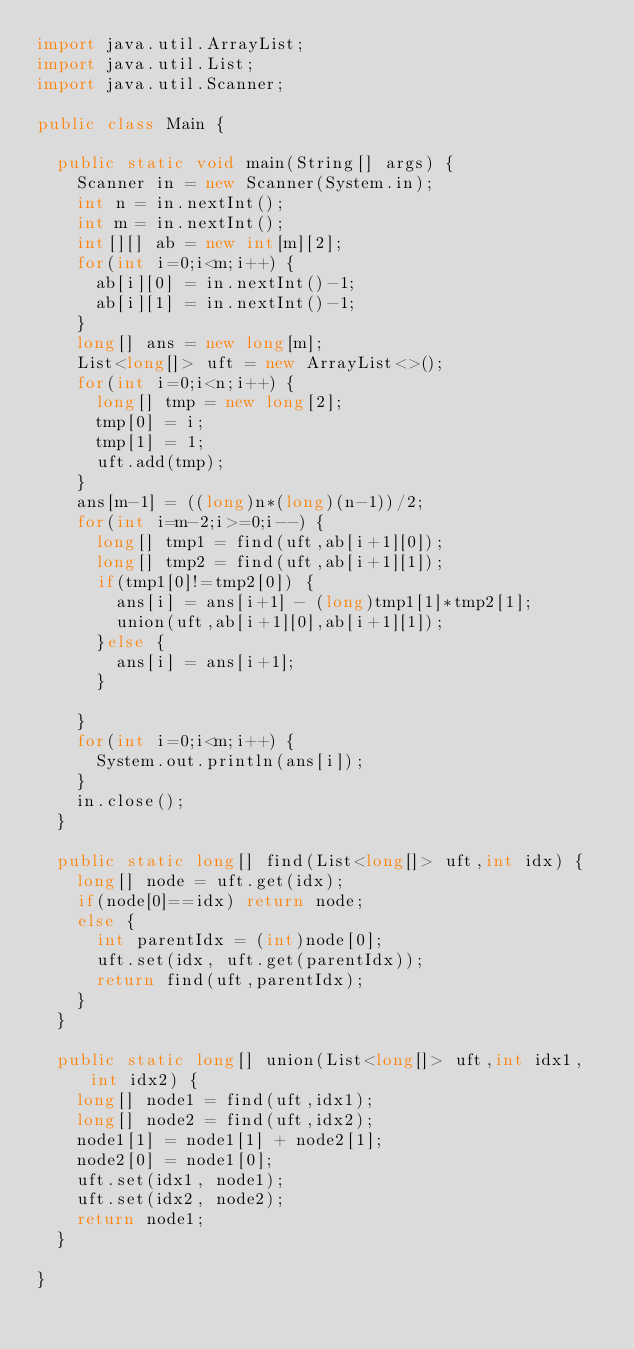<code> <loc_0><loc_0><loc_500><loc_500><_Java_>import java.util.ArrayList;
import java.util.List;
import java.util.Scanner;

public class Main {

	public static void main(String[] args) {
		Scanner in = new Scanner(System.in);
		int n = in.nextInt();
		int m = in.nextInt();
		int[][] ab = new int[m][2];
		for(int i=0;i<m;i++) {
			ab[i][0] = in.nextInt()-1;
			ab[i][1] = in.nextInt()-1;
		}
		long[] ans = new long[m];
		List<long[]> uft = new ArrayList<>();
		for(int i=0;i<n;i++) {
			long[] tmp = new long[2];
			tmp[0] = i;
			tmp[1] = 1;
			uft.add(tmp);
		}
		ans[m-1] = ((long)n*(long)(n-1))/2;
		for(int i=m-2;i>=0;i--) {
			long[] tmp1 = find(uft,ab[i+1][0]);
			long[] tmp2 = find(uft,ab[i+1][1]);
			if(tmp1[0]!=tmp2[0]) {
				ans[i] = ans[i+1] - (long)tmp1[1]*tmp2[1];
				union(uft,ab[i+1][0],ab[i+1][1]);
			}else {
				ans[i] = ans[i+1];
			}
			
		}
		for(int i=0;i<m;i++) {
			System.out.println(ans[i]);
		}
		in.close();
	}
	
	public static long[] find(List<long[]> uft,int idx) {
		long[] node = uft.get(idx);
		if(node[0]==idx) return node;
		else {
			int parentIdx = (int)node[0];
			uft.set(idx, uft.get(parentIdx));
			return find(uft,parentIdx);
		}
	}
	
	public static long[] union(List<long[]> uft,int idx1,int idx2) {
		long[] node1 = find(uft,idx1);
		long[] node2 = find(uft,idx2);
		node1[1] = node1[1] + node2[1];
		node2[0] = node1[0];
		uft.set(idx1, node1);
		uft.set(idx2, node2);
		return node1;
	}

}
</code> 